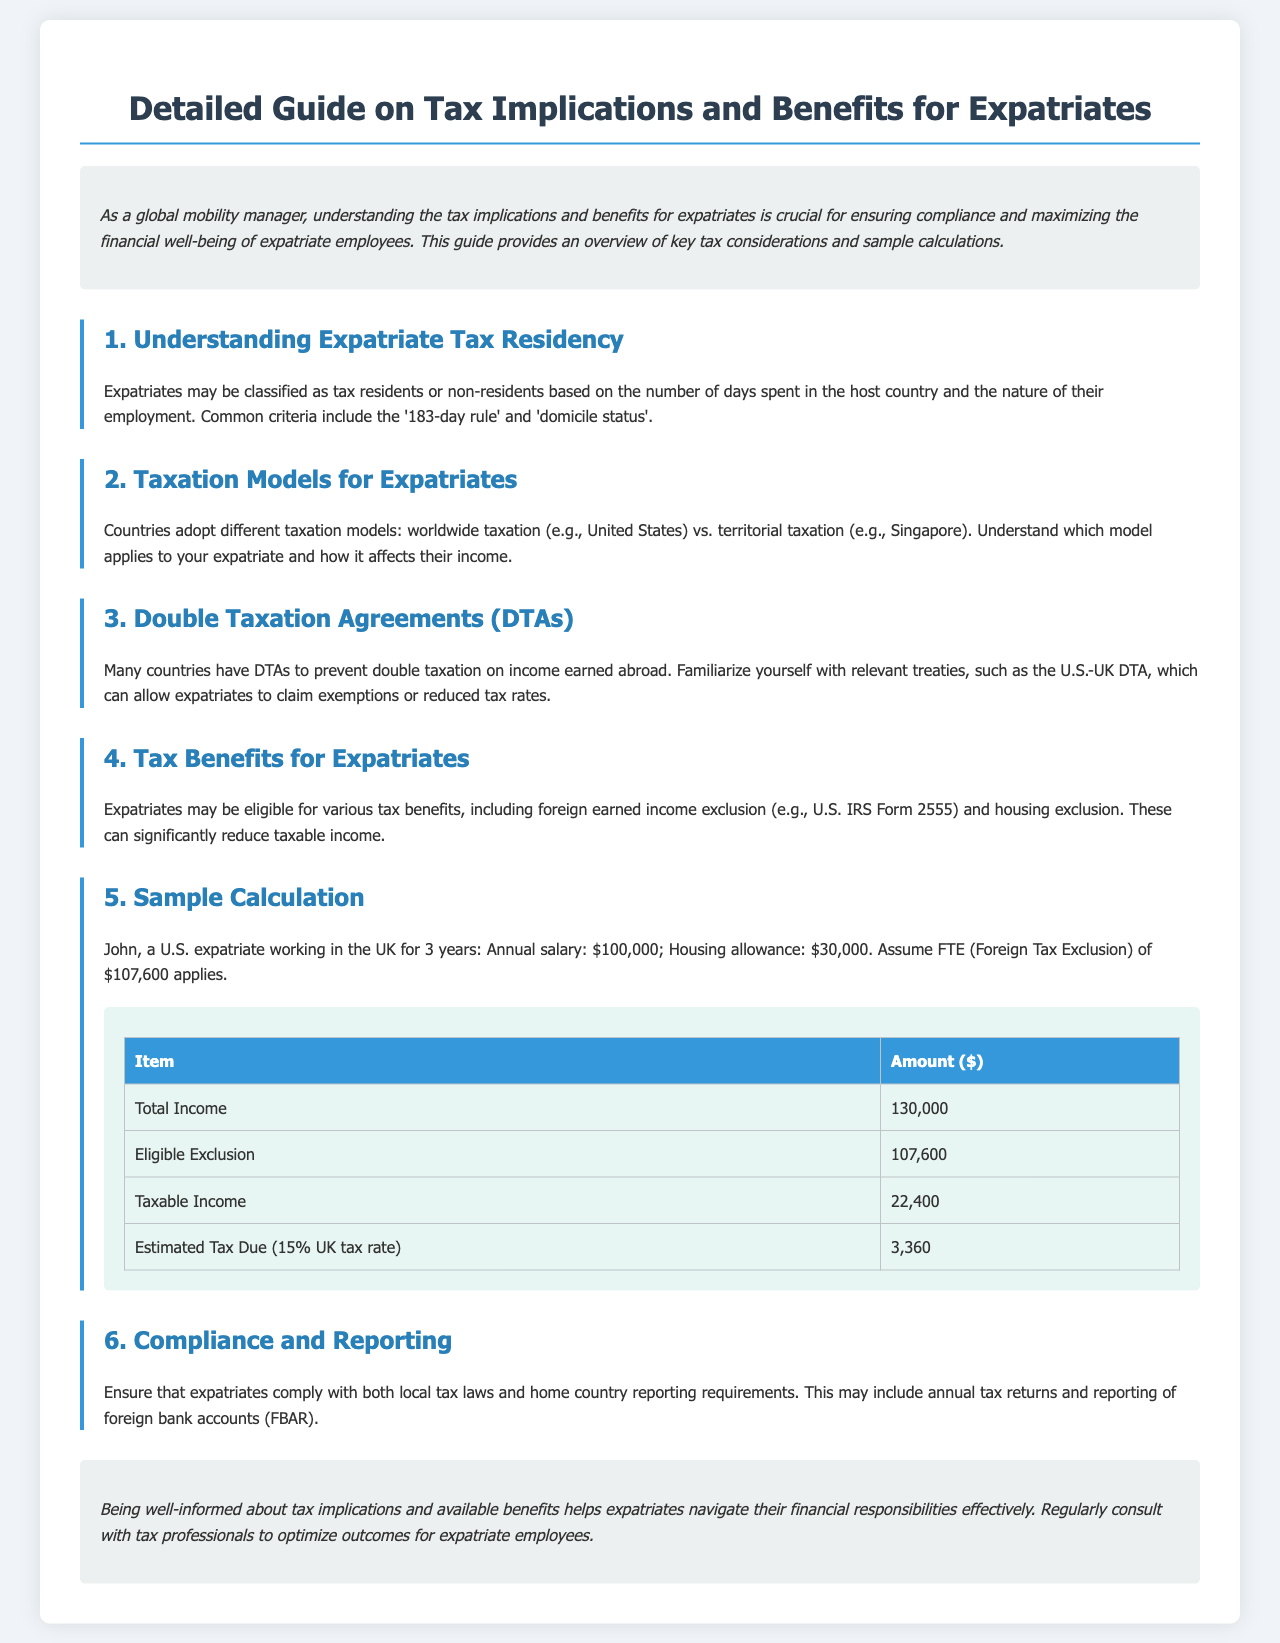What is the annual salary of John? John's annual salary is specified in the sample calculation section of the document as $100,000.
Answer: $100,000 What does FTE stand for? In the context of the sample calculation, FTE refers to Foreign Tax Exclusion.
Answer: Foreign Tax Exclusion What is the UK tax rate used in the sample calculation? The document states that the estimated tax due is calculated at a rate of 15% for the UK tax rate.
Answer: 15% How much is the total income in the sample calculation? The total income amount stated in the sample calculation is $130,000, combining salary and housing allowance.
Answer: $130,000 What is the eligible exclusion amount for John? The eligible exclusion amount for John in the sample calculation is listed as $107,600.
Answer: $107,600 What is the taxable income after exclusion in the example? The taxable income after applying the eligible exclusion is provided as $22,400.
Answer: $22,400 How much estimated tax is due for John? The estimated tax due calculated based on the taxable income and UK tax rate is $3,360.
Answer: $3,360 What type of treaty helps prevent double taxation? The document mentions Double Taxation Agreements (DTAs) as the treaties that prevent double taxation.
Answer: Double Taxation Agreements Which section describes tax residency criteria? The section titled "Understanding Expatriate Tax Residency" describes the criteria for tax residency.
Answer: Understanding Expatriate Tax Residency 